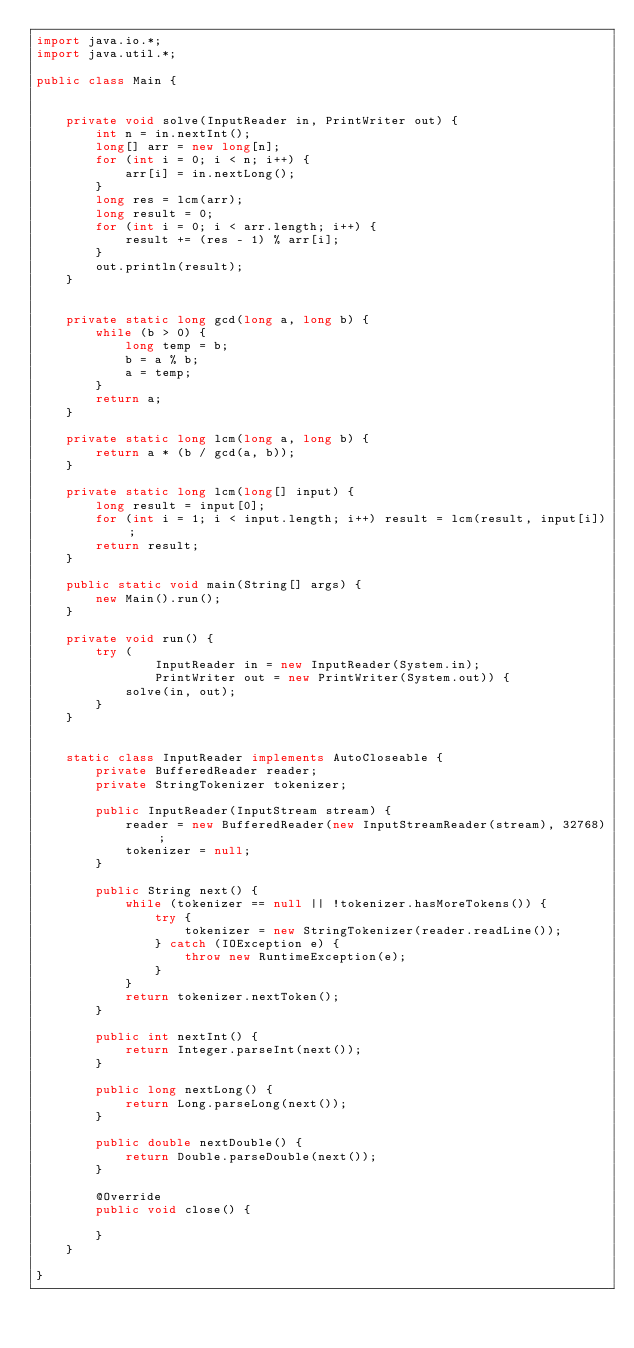Convert code to text. <code><loc_0><loc_0><loc_500><loc_500><_Java_>import java.io.*;
import java.util.*;

public class Main {


    private void solve(InputReader in, PrintWriter out) {
        int n = in.nextInt();
        long[] arr = new long[n];
        for (int i = 0; i < n; i++) {
            arr[i] = in.nextLong();
        }
        long res = lcm(arr);
        long result = 0;
        for (int i = 0; i < arr.length; i++) {
            result += (res - 1) % arr[i];
        }
        out.println(result);
    }


    private static long gcd(long a, long b) {
        while (b > 0) {
            long temp = b;
            b = a % b;
            a = temp;
        }
        return a;
    }

    private static long lcm(long a, long b) {
        return a * (b / gcd(a, b));
    }

    private static long lcm(long[] input) {
        long result = input[0];
        for (int i = 1; i < input.length; i++) result = lcm(result, input[i]);
        return result;
    }

    public static void main(String[] args) {
        new Main().run();
    }

    private void run() {
        try (
                InputReader in = new InputReader(System.in);
                PrintWriter out = new PrintWriter(System.out)) {
            solve(in, out);
        }
    }


    static class InputReader implements AutoCloseable {
        private BufferedReader reader;
        private StringTokenizer tokenizer;

        public InputReader(InputStream stream) {
            reader = new BufferedReader(new InputStreamReader(stream), 32768);
            tokenizer = null;
        }

        public String next() {
            while (tokenizer == null || !tokenizer.hasMoreTokens()) {
                try {
                    tokenizer = new StringTokenizer(reader.readLine());
                } catch (IOException e) {
                    throw new RuntimeException(e);
                }
            }
            return tokenizer.nextToken();
        }

        public int nextInt() {
            return Integer.parseInt(next());
        }

        public long nextLong() {
            return Long.parseLong(next());
        }

        public double nextDouble() {
            return Double.parseDouble(next());
        }

        @Override
        public void close() {

        }
    }

}
</code> 